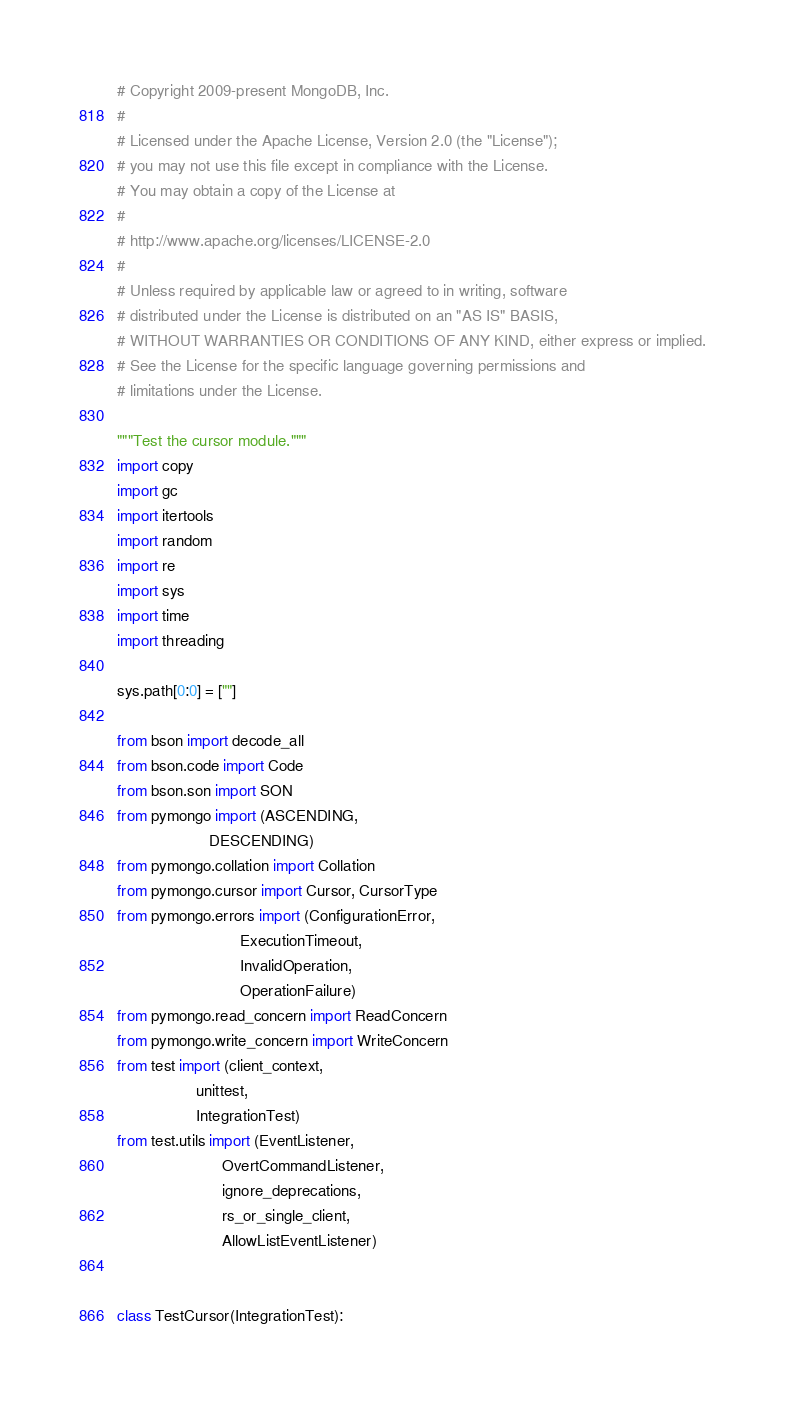<code> <loc_0><loc_0><loc_500><loc_500><_Python_># Copyright 2009-present MongoDB, Inc.
#
# Licensed under the Apache License, Version 2.0 (the "License");
# you may not use this file except in compliance with the License.
# You may obtain a copy of the License at
#
# http://www.apache.org/licenses/LICENSE-2.0
#
# Unless required by applicable law or agreed to in writing, software
# distributed under the License is distributed on an "AS IS" BASIS,
# WITHOUT WARRANTIES OR CONDITIONS OF ANY KIND, either express or implied.
# See the License for the specific language governing permissions and
# limitations under the License.

"""Test the cursor module."""
import copy
import gc
import itertools
import random
import re
import sys
import time
import threading

sys.path[0:0] = [""]

from bson import decode_all
from bson.code import Code
from bson.son import SON
from pymongo import (ASCENDING,
                     DESCENDING)
from pymongo.collation import Collation
from pymongo.cursor import Cursor, CursorType
from pymongo.errors import (ConfigurationError,
                            ExecutionTimeout,
                            InvalidOperation,
                            OperationFailure)
from pymongo.read_concern import ReadConcern
from pymongo.write_concern import WriteConcern
from test import (client_context,
                  unittest,
                  IntegrationTest)
from test.utils import (EventListener,
                        OvertCommandListener,
                        ignore_deprecations,
                        rs_or_single_client,
                        AllowListEventListener)


class TestCursor(IntegrationTest):</code> 